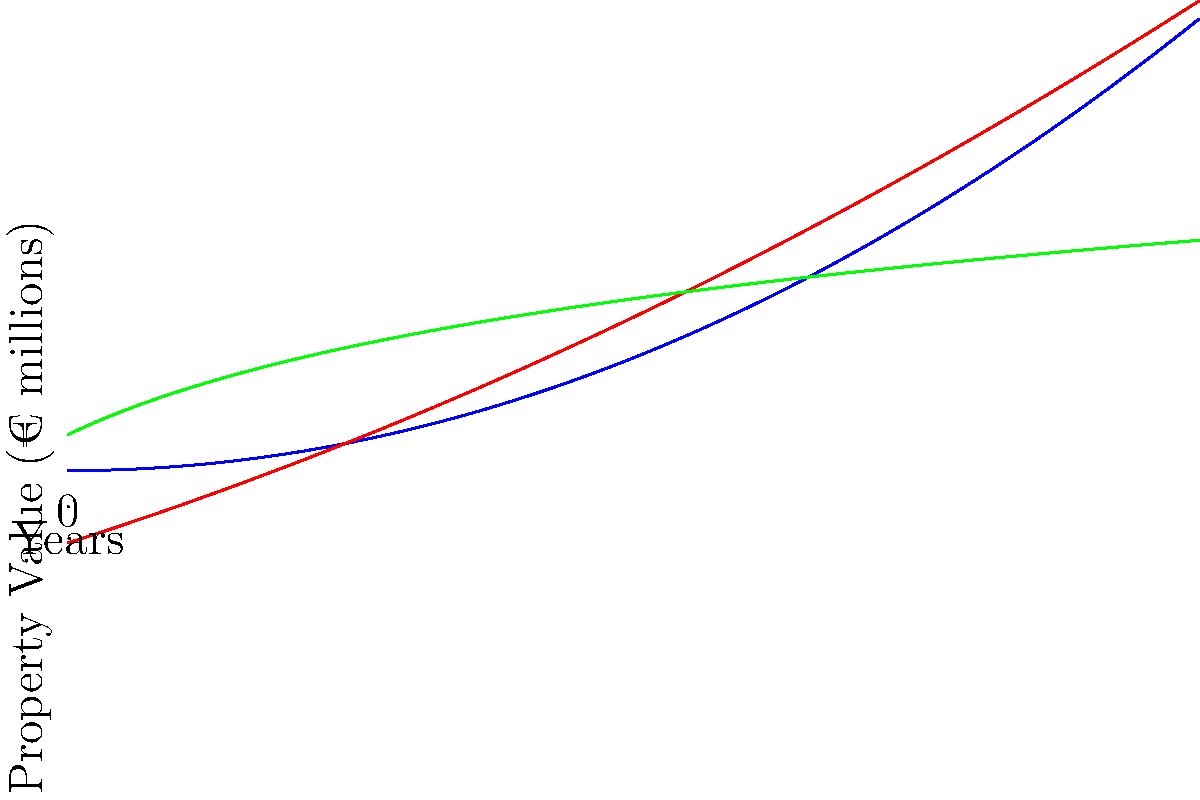Based on the line graph showing property value trends in London, Paris, and Berlin over 5 years, which city demonstrates the most consistent and stable growth rate in property values? To determine which city has the most consistent and stable growth rate, we need to analyze the shape and slope of each line:

1. London (Blue line):
   - Shows a curved, parabolic growth
   - Growth rate increases over time (steeper slope as years progress)
   - Not consistent or stable

2. Paris (Red line):
   - Also shows a curved, parabolic growth
   - Growth rate increases over time, but less dramatically than London
   - Not consistent or stable

3. Berlin (Green line):
   - Shows a logarithmic growth curve
   - Growth rate is higher at the beginning and gradually decreases
   - While not perfectly linear, it's the most consistent among the three

The most consistent and stable growth rate would be represented by a line with the least variation in its slope. Among the three cities, Berlin's property value trend line (green) shows the most consistent growth rate. It starts with a higher growth rate and gradually levels off, but maintains a more steady increase compared to the accelerating growth rates of London and Paris.
Answer: Berlin 